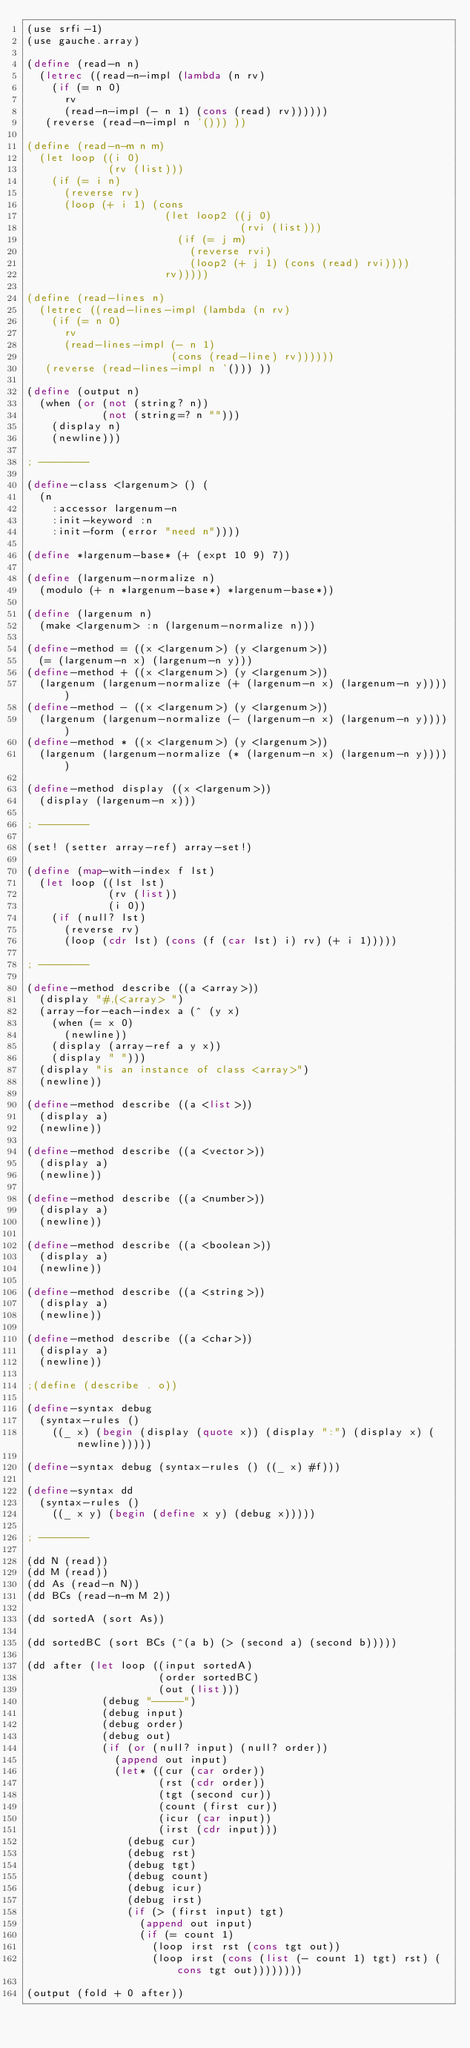Convert code to text. <code><loc_0><loc_0><loc_500><loc_500><_Scheme_>(use srfi-1)
(use gauche.array)

(define (read-n n)
  (letrec ((read-n-impl (lambda (n rv)
    (if (= n 0)
      rv
      (read-n-impl (- n 1) (cons (read) rv))))))
   (reverse (read-n-impl n '())) ))

(define (read-n-m n m)
  (let loop ((i 0)
             (rv (list)))
    (if (= i n)
      (reverse rv)
      (loop (+ i 1) (cons 
                      (let loop2 ((j 0)
                                  (rvi (list)))
                        (if (= j m)
                          (reverse rvi)
                          (loop2 (+ j 1) (cons (read) rvi))))
                      rv)))))

(define (read-lines n)
  (letrec ((read-lines-impl (lambda (n rv)
    (if (= n 0)
      rv
      (read-lines-impl (- n 1)
                       (cons (read-line) rv))))))
   (reverse (read-lines-impl n '())) ))

(define (output n)
  (when (or (not (string? n))
            (not (string=? n "")))
    (display n) 
    (newline)))

; --------

(define-class <largenum> () (
  (n
    :accessor largenum-n
    :init-keyword :n
    :init-form (error "need n"))))

(define *largenum-base* (+ (expt 10 9) 7))

(define (largenum-normalize n)
  (modulo (+ n *largenum-base*) *largenum-base*))

(define (largenum n)
  (make <largenum> :n (largenum-normalize n)))

(define-method = ((x <largenum>) (y <largenum>))
  (= (largenum-n x) (largenum-n y)))
(define-method + ((x <largenum>) (y <largenum>))
  (largenum (largenum-normalize (+ (largenum-n x) (largenum-n y)))))
(define-method - ((x <largenum>) (y <largenum>))
  (largenum (largenum-normalize (- (largenum-n x) (largenum-n y)))))
(define-method * ((x <largenum>) (y <largenum>))
  (largenum (largenum-normalize (* (largenum-n x) (largenum-n y)))))

(define-method display ((x <largenum>))
  (display (largenum-n x)))

; --------

(set! (setter array-ref) array-set!)

(define (map-with-index f lst)
  (let loop ((lst lst)
             (rv (list))
             (i 0))
    (if (null? lst)
      (reverse rv)
      (loop (cdr lst) (cons (f (car lst) i) rv) (+ i 1)))))

; --------

(define-method describe ((a <array>))
  (display "#,(<array> ")
  (array-for-each-index a (^ (y x)
    (when (= x 0)
      (newline))
    (display (array-ref a y x))
    (display " ")))
  (display "is an instance of class <array>")
  (newline))

(define-method describe ((a <list>))
  (display a)
  (newline))

(define-method describe ((a <vector>))
  (display a)
  (newline))

(define-method describe ((a <number>))
  (display a)
  (newline))

(define-method describe ((a <boolean>))
  (display a)
  (newline))

(define-method describe ((a <string>))
  (display a)
  (newline))

(define-method describe ((a <char>))
  (display a)
  (newline))

;(define (describe . o))

(define-syntax debug
  (syntax-rules ()
    ((_ x) (begin (display (quote x)) (display ":") (display x) (newline)))))

(define-syntax debug (syntax-rules () ((_ x) #f))) 

(define-syntax dd
  (syntax-rules ()
    ((_ x y) (begin (define x y) (debug x)))))

; --------

(dd N (read))
(dd M (read))
(dd As (read-n N))
(dd BCs (read-n-m M 2))

(dd sortedA (sort As))

(dd sortedBC (sort BCs (^(a b) (> (second a) (second b)))))

(dd after (let loop ((input sortedA)
                     (order sortedBC)
                     (out (list)))
            (debug "-----")
            (debug input)
            (debug order)
            (debug out)
            (if (or (null? input) (null? order))
              (append out input)
              (let* ((cur (car order))
                     (rst (cdr order))
                     (tgt (second cur))
                     (count (first cur))
                     (icur (car input))
                     (irst (cdr input)))
                (debug cur)
                (debug rst)
                (debug tgt)
                (debug count)
                (debug icur)
                (debug irst)
                (if (> (first input) tgt)
                  (append out input)
                  (if (= count 1)
                    (loop irst rst (cons tgt out))
                    (loop irst (cons (list (- count 1) tgt) rst) (cons tgt out))))))))

(output (fold + 0 after))
</code> 